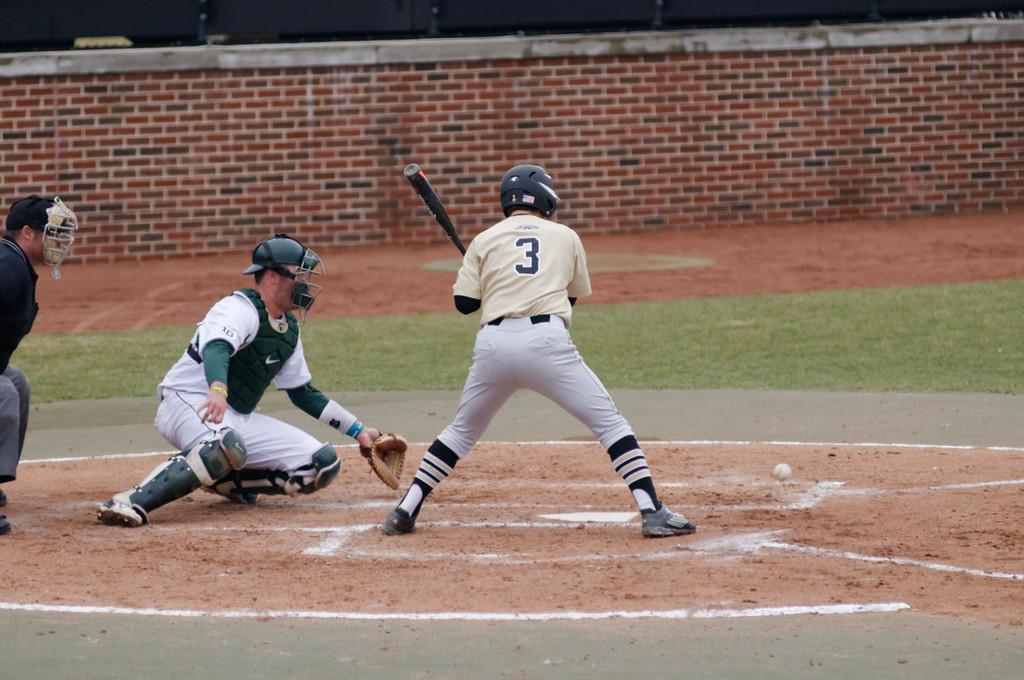<image>
Relay a brief, clear account of the picture shown. A baseball player wearing white and the number 3 prepares to face the ball. 